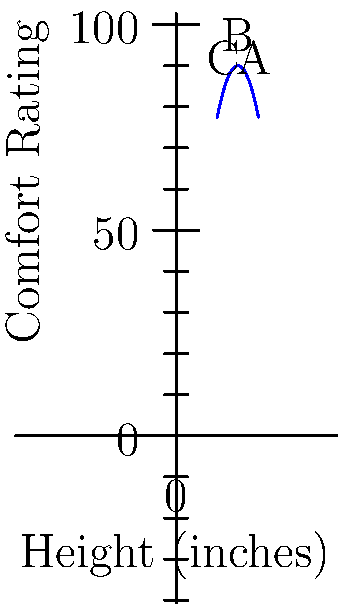The graph shows comfort ratings for wheelchair armrest heights. Which height (in inches) provides the maximum comfort based on the data? To determine the most ergonomic armrest height, we need to find the peak of the comfort rating curve. Let's analyze the graph step-by-step:

1. The graph shows a parabolic curve with the vertex at the top.
2. The vertex of a parabola represents the maximum point of the function.
3. We can see that the curve reaches its highest point at point B.
4. The x-coordinate of point B corresponds to the armrest height that provides maximum comfort.
5. By examining the x-axis, we can see that point B is located at 15 inches.

Therefore, the armrest height that provides the maximum comfort is 15 inches.
Answer: 15 inches 